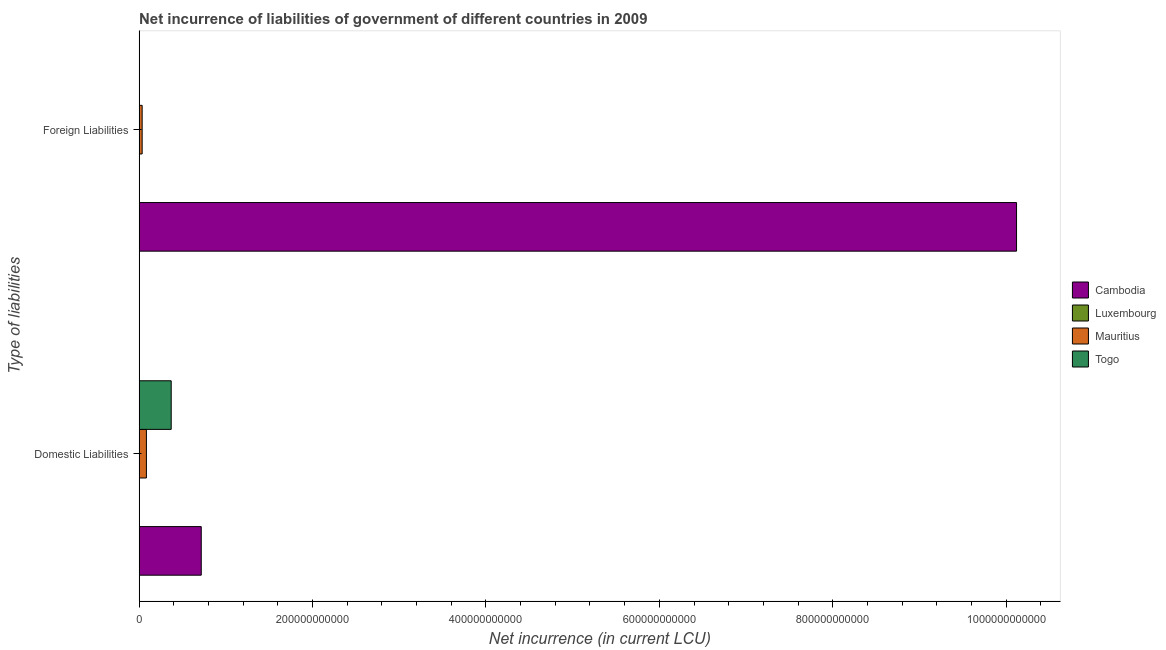Are the number of bars on each tick of the Y-axis equal?
Provide a short and direct response. No. What is the label of the 2nd group of bars from the top?
Offer a terse response. Domestic Liabilities. What is the net incurrence of foreign liabilities in Mauritius?
Your answer should be very brief. 3.51e+09. Across all countries, what is the maximum net incurrence of domestic liabilities?
Keep it short and to the point. 7.17e+1. In which country was the net incurrence of domestic liabilities maximum?
Make the answer very short. Cambodia. What is the total net incurrence of foreign liabilities in the graph?
Give a very brief answer. 1.02e+12. What is the difference between the net incurrence of domestic liabilities in Togo and that in Cambodia?
Provide a succinct answer. -3.47e+1. What is the difference between the net incurrence of foreign liabilities in Luxembourg and the net incurrence of domestic liabilities in Togo?
Your answer should be very brief. -3.70e+1. What is the average net incurrence of domestic liabilities per country?
Offer a terse response. 2.93e+1. What is the difference between the net incurrence of foreign liabilities and net incurrence of domestic liabilities in Luxembourg?
Make the answer very short. -1.12e+08. In how many countries, is the net incurrence of domestic liabilities greater than 560000000000 LCU?
Offer a terse response. 0. What is the ratio of the net incurrence of foreign liabilities in Luxembourg to that in Mauritius?
Keep it short and to the point. 0. In how many countries, is the net incurrence of foreign liabilities greater than the average net incurrence of foreign liabilities taken over all countries?
Give a very brief answer. 1. What is the difference between two consecutive major ticks on the X-axis?
Provide a succinct answer. 2.00e+11. Are the values on the major ticks of X-axis written in scientific E-notation?
Keep it short and to the point. No. How many legend labels are there?
Give a very brief answer. 4. How are the legend labels stacked?
Ensure brevity in your answer.  Vertical. What is the title of the graph?
Give a very brief answer. Net incurrence of liabilities of government of different countries in 2009. Does "Croatia" appear as one of the legend labels in the graph?
Make the answer very short. No. What is the label or title of the X-axis?
Ensure brevity in your answer.  Net incurrence (in current LCU). What is the label or title of the Y-axis?
Offer a terse response. Type of liabilities. What is the Net incurrence (in current LCU) of Cambodia in Domestic Liabilities?
Offer a very short reply. 7.17e+1. What is the Net incurrence (in current LCU) of Luxembourg in Domestic Liabilities?
Your answer should be compact. 1.18e+08. What is the Net incurrence (in current LCU) in Mauritius in Domestic Liabilities?
Ensure brevity in your answer.  8.43e+09. What is the Net incurrence (in current LCU) in Togo in Domestic Liabilities?
Ensure brevity in your answer.  3.70e+1. What is the Net incurrence (in current LCU) of Cambodia in Foreign Liabilities?
Offer a very short reply. 1.01e+12. What is the Net incurrence (in current LCU) of Luxembourg in Foreign Liabilities?
Your answer should be very brief. 6.20e+06. What is the Net incurrence (in current LCU) of Mauritius in Foreign Liabilities?
Make the answer very short. 3.51e+09. Across all Type of liabilities, what is the maximum Net incurrence (in current LCU) in Cambodia?
Make the answer very short. 1.01e+12. Across all Type of liabilities, what is the maximum Net incurrence (in current LCU) of Luxembourg?
Provide a short and direct response. 1.18e+08. Across all Type of liabilities, what is the maximum Net incurrence (in current LCU) in Mauritius?
Give a very brief answer. 8.43e+09. Across all Type of liabilities, what is the maximum Net incurrence (in current LCU) of Togo?
Give a very brief answer. 3.70e+1. Across all Type of liabilities, what is the minimum Net incurrence (in current LCU) of Cambodia?
Provide a short and direct response. 7.17e+1. Across all Type of liabilities, what is the minimum Net incurrence (in current LCU) in Luxembourg?
Ensure brevity in your answer.  6.20e+06. Across all Type of liabilities, what is the minimum Net incurrence (in current LCU) in Mauritius?
Your answer should be very brief. 3.51e+09. What is the total Net incurrence (in current LCU) of Cambodia in the graph?
Provide a short and direct response. 1.08e+12. What is the total Net incurrence (in current LCU) in Luxembourg in the graph?
Ensure brevity in your answer.  1.24e+08. What is the total Net incurrence (in current LCU) in Mauritius in the graph?
Your answer should be very brief. 1.19e+1. What is the total Net incurrence (in current LCU) of Togo in the graph?
Your response must be concise. 3.70e+1. What is the difference between the Net incurrence (in current LCU) of Cambodia in Domestic Liabilities and that in Foreign Liabilities?
Offer a terse response. -9.40e+11. What is the difference between the Net incurrence (in current LCU) in Luxembourg in Domestic Liabilities and that in Foreign Liabilities?
Ensure brevity in your answer.  1.12e+08. What is the difference between the Net incurrence (in current LCU) of Mauritius in Domestic Liabilities and that in Foreign Liabilities?
Your response must be concise. 4.91e+09. What is the difference between the Net incurrence (in current LCU) in Cambodia in Domestic Liabilities and the Net incurrence (in current LCU) in Luxembourg in Foreign Liabilities?
Offer a terse response. 7.17e+1. What is the difference between the Net incurrence (in current LCU) in Cambodia in Domestic Liabilities and the Net incurrence (in current LCU) in Mauritius in Foreign Liabilities?
Keep it short and to the point. 6.82e+1. What is the difference between the Net incurrence (in current LCU) of Luxembourg in Domestic Liabilities and the Net incurrence (in current LCU) of Mauritius in Foreign Liabilities?
Offer a very short reply. -3.40e+09. What is the average Net incurrence (in current LCU) in Cambodia per Type of liabilities?
Keep it short and to the point. 5.42e+11. What is the average Net incurrence (in current LCU) of Luxembourg per Type of liabilities?
Give a very brief answer. 6.22e+07. What is the average Net incurrence (in current LCU) of Mauritius per Type of liabilities?
Offer a very short reply. 5.97e+09. What is the average Net incurrence (in current LCU) of Togo per Type of liabilities?
Your response must be concise. 1.85e+1. What is the difference between the Net incurrence (in current LCU) in Cambodia and Net incurrence (in current LCU) in Luxembourg in Domestic Liabilities?
Your response must be concise. 7.16e+1. What is the difference between the Net incurrence (in current LCU) of Cambodia and Net incurrence (in current LCU) of Mauritius in Domestic Liabilities?
Ensure brevity in your answer.  6.33e+1. What is the difference between the Net incurrence (in current LCU) of Cambodia and Net incurrence (in current LCU) of Togo in Domestic Liabilities?
Give a very brief answer. 3.47e+1. What is the difference between the Net incurrence (in current LCU) in Luxembourg and Net incurrence (in current LCU) in Mauritius in Domestic Liabilities?
Your response must be concise. -8.31e+09. What is the difference between the Net incurrence (in current LCU) in Luxembourg and Net incurrence (in current LCU) in Togo in Domestic Liabilities?
Your answer should be compact. -3.69e+1. What is the difference between the Net incurrence (in current LCU) in Mauritius and Net incurrence (in current LCU) in Togo in Domestic Liabilities?
Your response must be concise. -2.86e+1. What is the difference between the Net incurrence (in current LCU) in Cambodia and Net incurrence (in current LCU) in Luxembourg in Foreign Liabilities?
Offer a terse response. 1.01e+12. What is the difference between the Net incurrence (in current LCU) in Cambodia and Net incurrence (in current LCU) in Mauritius in Foreign Liabilities?
Offer a terse response. 1.01e+12. What is the difference between the Net incurrence (in current LCU) of Luxembourg and Net incurrence (in current LCU) of Mauritius in Foreign Liabilities?
Make the answer very short. -3.51e+09. What is the ratio of the Net incurrence (in current LCU) in Cambodia in Domestic Liabilities to that in Foreign Liabilities?
Ensure brevity in your answer.  0.07. What is the ratio of the Net incurrence (in current LCU) of Luxembourg in Domestic Liabilities to that in Foreign Liabilities?
Your answer should be compact. 19.07. What is the ratio of the Net incurrence (in current LCU) of Mauritius in Domestic Liabilities to that in Foreign Liabilities?
Give a very brief answer. 2.4. What is the difference between the highest and the second highest Net incurrence (in current LCU) of Cambodia?
Offer a very short reply. 9.40e+11. What is the difference between the highest and the second highest Net incurrence (in current LCU) of Luxembourg?
Your answer should be compact. 1.12e+08. What is the difference between the highest and the second highest Net incurrence (in current LCU) of Mauritius?
Provide a succinct answer. 4.91e+09. What is the difference between the highest and the lowest Net incurrence (in current LCU) in Cambodia?
Give a very brief answer. 9.40e+11. What is the difference between the highest and the lowest Net incurrence (in current LCU) in Luxembourg?
Your response must be concise. 1.12e+08. What is the difference between the highest and the lowest Net incurrence (in current LCU) of Mauritius?
Ensure brevity in your answer.  4.91e+09. What is the difference between the highest and the lowest Net incurrence (in current LCU) in Togo?
Ensure brevity in your answer.  3.70e+1. 